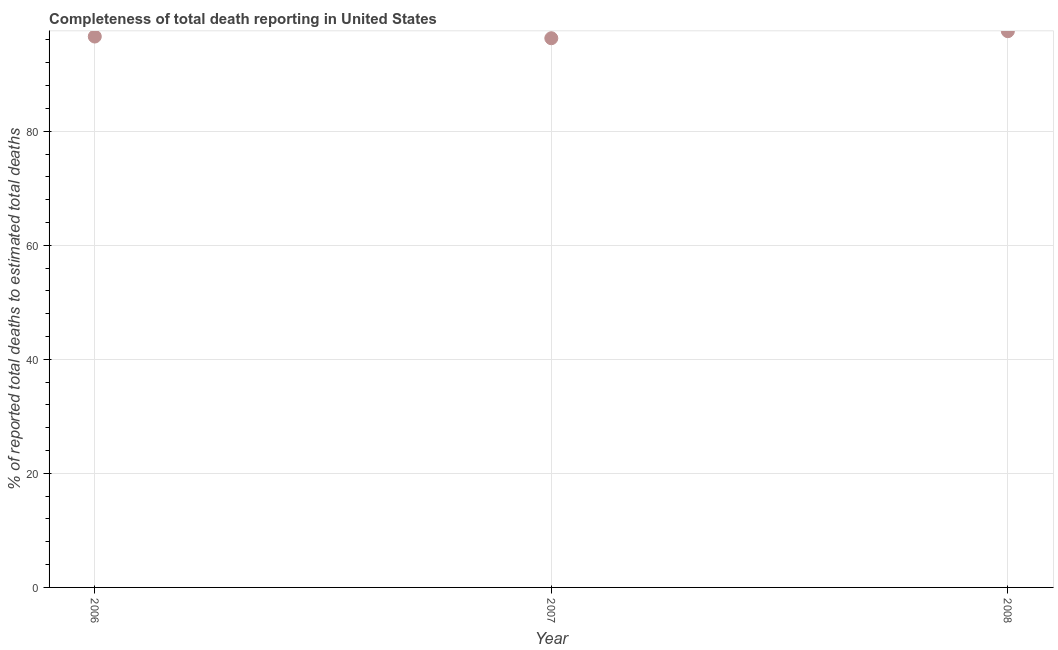What is the completeness of total death reports in 2006?
Make the answer very short. 96.6. Across all years, what is the maximum completeness of total death reports?
Ensure brevity in your answer.  97.54. Across all years, what is the minimum completeness of total death reports?
Your answer should be compact. 96.31. In which year was the completeness of total death reports minimum?
Provide a short and direct response. 2007. What is the sum of the completeness of total death reports?
Make the answer very short. 290.45. What is the difference between the completeness of total death reports in 2006 and 2007?
Provide a succinct answer. 0.3. What is the average completeness of total death reports per year?
Your answer should be compact. 96.82. What is the median completeness of total death reports?
Your answer should be very brief. 96.6. What is the ratio of the completeness of total death reports in 2007 to that in 2008?
Offer a very short reply. 0.99. Is the completeness of total death reports in 2006 less than that in 2007?
Offer a terse response. No. Is the difference between the completeness of total death reports in 2006 and 2008 greater than the difference between any two years?
Offer a terse response. No. What is the difference between the highest and the second highest completeness of total death reports?
Provide a succinct answer. 0.94. What is the difference between the highest and the lowest completeness of total death reports?
Provide a short and direct response. 1.24. In how many years, is the completeness of total death reports greater than the average completeness of total death reports taken over all years?
Provide a succinct answer. 1. Does the completeness of total death reports monotonically increase over the years?
Make the answer very short. No. How many years are there in the graph?
Provide a succinct answer. 3. What is the title of the graph?
Offer a terse response. Completeness of total death reporting in United States. What is the label or title of the X-axis?
Your answer should be compact. Year. What is the label or title of the Y-axis?
Offer a very short reply. % of reported total deaths to estimated total deaths. What is the % of reported total deaths to estimated total deaths in 2006?
Give a very brief answer. 96.6. What is the % of reported total deaths to estimated total deaths in 2007?
Your answer should be compact. 96.31. What is the % of reported total deaths to estimated total deaths in 2008?
Offer a terse response. 97.54. What is the difference between the % of reported total deaths to estimated total deaths in 2006 and 2007?
Your response must be concise. 0.3. What is the difference between the % of reported total deaths to estimated total deaths in 2006 and 2008?
Keep it short and to the point. -0.94. What is the difference between the % of reported total deaths to estimated total deaths in 2007 and 2008?
Your answer should be very brief. -1.24. What is the ratio of the % of reported total deaths to estimated total deaths in 2006 to that in 2007?
Make the answer very short. 1. What is the ratio of the % of reported total deaths to estimated total deaths in 2006 to that in 2008?
Make the answer very short. 0.99. 